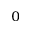Convert formula to latex. <formula><loc_0><loc_0><loc_500><loc_500>_ { 0 }</formula> 